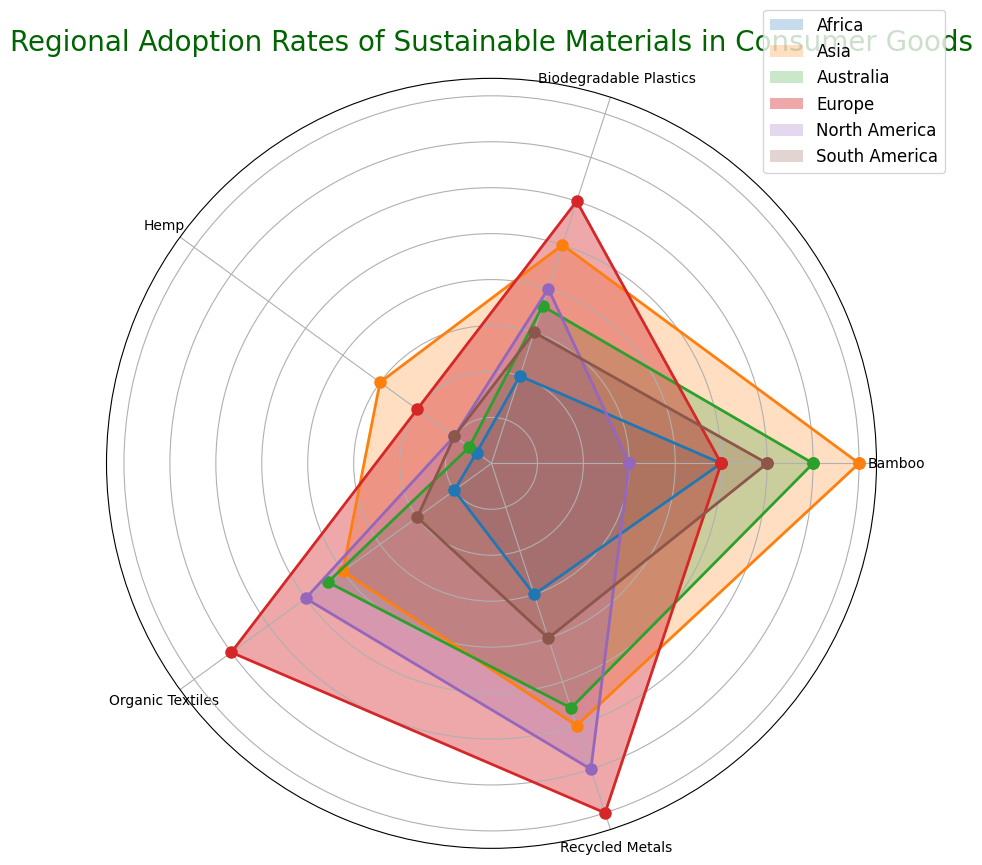What's the adoption rate of Recycled Metals in Europe? Look at the segment labeled "Recycled Metals" under the region "Europe" on the rose chart and read the value.
Answer: 40 Which region has the highest adoption rate for Bamboo? Compare the Bamboo segments for all regions and identify which one is the largest.
Answer: Asia Which material has the lowest adoption rate in South America? Look for the smallest segment within the South America region on the chart.
Answer: Hemp What's the sum of the adoption rates of Organic Textiles and Bamboo in North America? Add the values of the Organic Textiles and Bamboo segments in North America: (25 + 15).
Answer: 40 Is the adoption rate of Hemp in Asia greater than the adoption rate of Hemp in Australia? Compare the segments for Hemp in Asia and Australia by checking their lengths; Asia has a value of 15 and Australia has a value of 3.
Answer: Yes What is the average adoption rate of Biodegradable Plastics across all regions? Add the adoption rates of Biodegradable Plastics across all regions and divide by the number of regions: (20 + 30 + 25 + 15 + 10 + 18) / 6.
Answer: 19.67 Which region has a higher adoption rate for Organic Textiles, North America or Africa? Compare the segments for Organic Textiles in North America and Africa; North America has 25, and Africa has 5.
Answer: North America How does the adoption rate of Recycled Metals in North America compare to that in Africa? Compare the Recycled Metals segments between North America (35) and Africa (15).
Answer: Higher in North America Between Europe and Australia, which region has the higher overall adoption rate for sustainable materials in consumer goods? Calculate the total adoption rates for all materials in Europe and Australia and compare: Europe (30+40+35+25+10 = 140) and Australia (18+28+22+35+3 = 106).
Answer: Europe Are the adoption rates of Bamboo and Organic Textiles in Australia equal? Compare the segments for Bamboo and Organic Textiles in Australia; Bamboo is 35 and Organic Textiles is 22.
Answer: No 